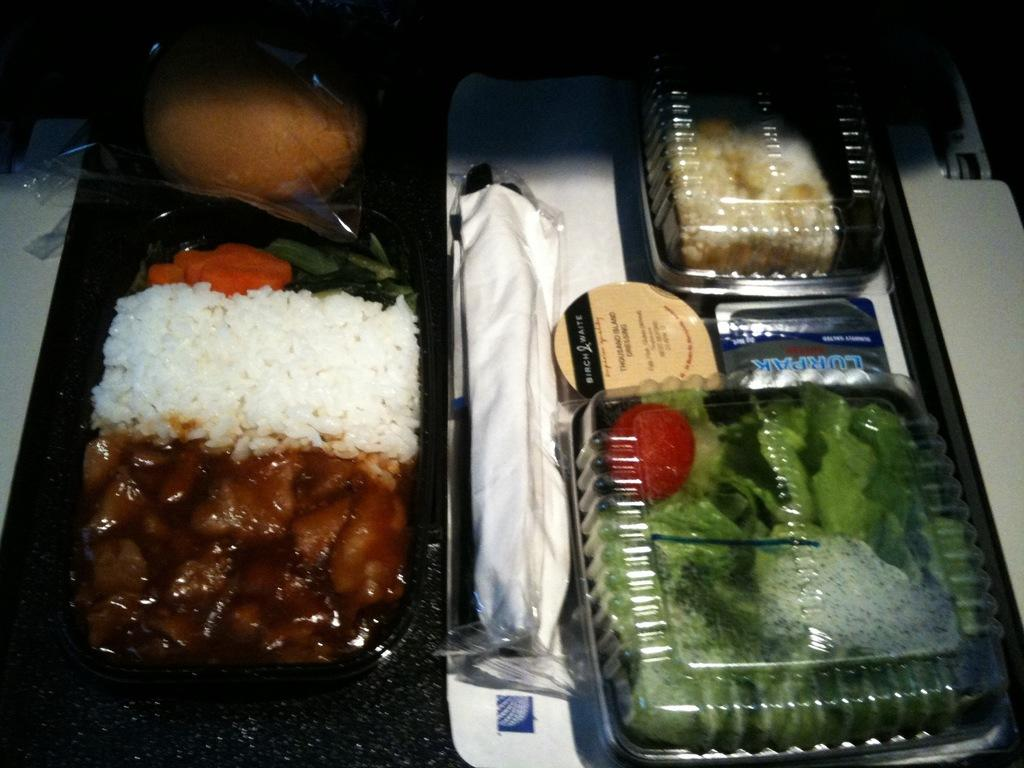<image>
Present a compact description of the photo's key features. Bitch & Waite type products and vegetables that are on a table. 